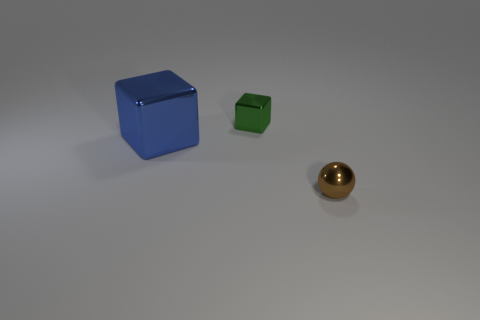Add 3 big brown balls. How many objects exist? 6 Subtract all green blocks. How many blocks are left? 1 Subtract 0 blue cylinders. How many objects are left? 3 Subtract all cubes. How many objects are left? 1 Subtract 1 blocks. How many blocks are left? 1 Subtract all blue blocks. Subtract all red cylinders. How many blocks are left? 1 Subtract all big green metal objects. Subtract all green shiny cubes. How many objects are left? 2 Add 2 blue metallic things. How many blue metallic things are left? 3 Add 3 tiny brown shiny things. How many tiny brown shiny things exist? 4 